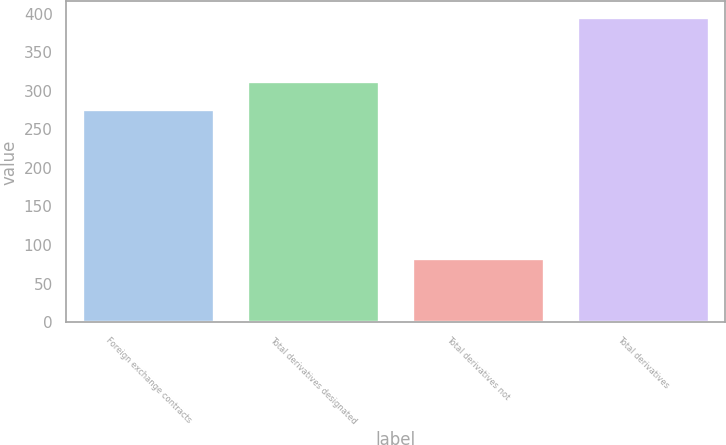Convert chart. <chart><loc_0><loc_0><loc_500><loc_500><bar_chart><fcel>Foreign exchange contracts<fcel>Total derivatives designated<fcel>Total derivatives not<fcel>Total derivatives<nl><fcel>277<fcel>313<fcel>83<fcel>396<nl></chart> 